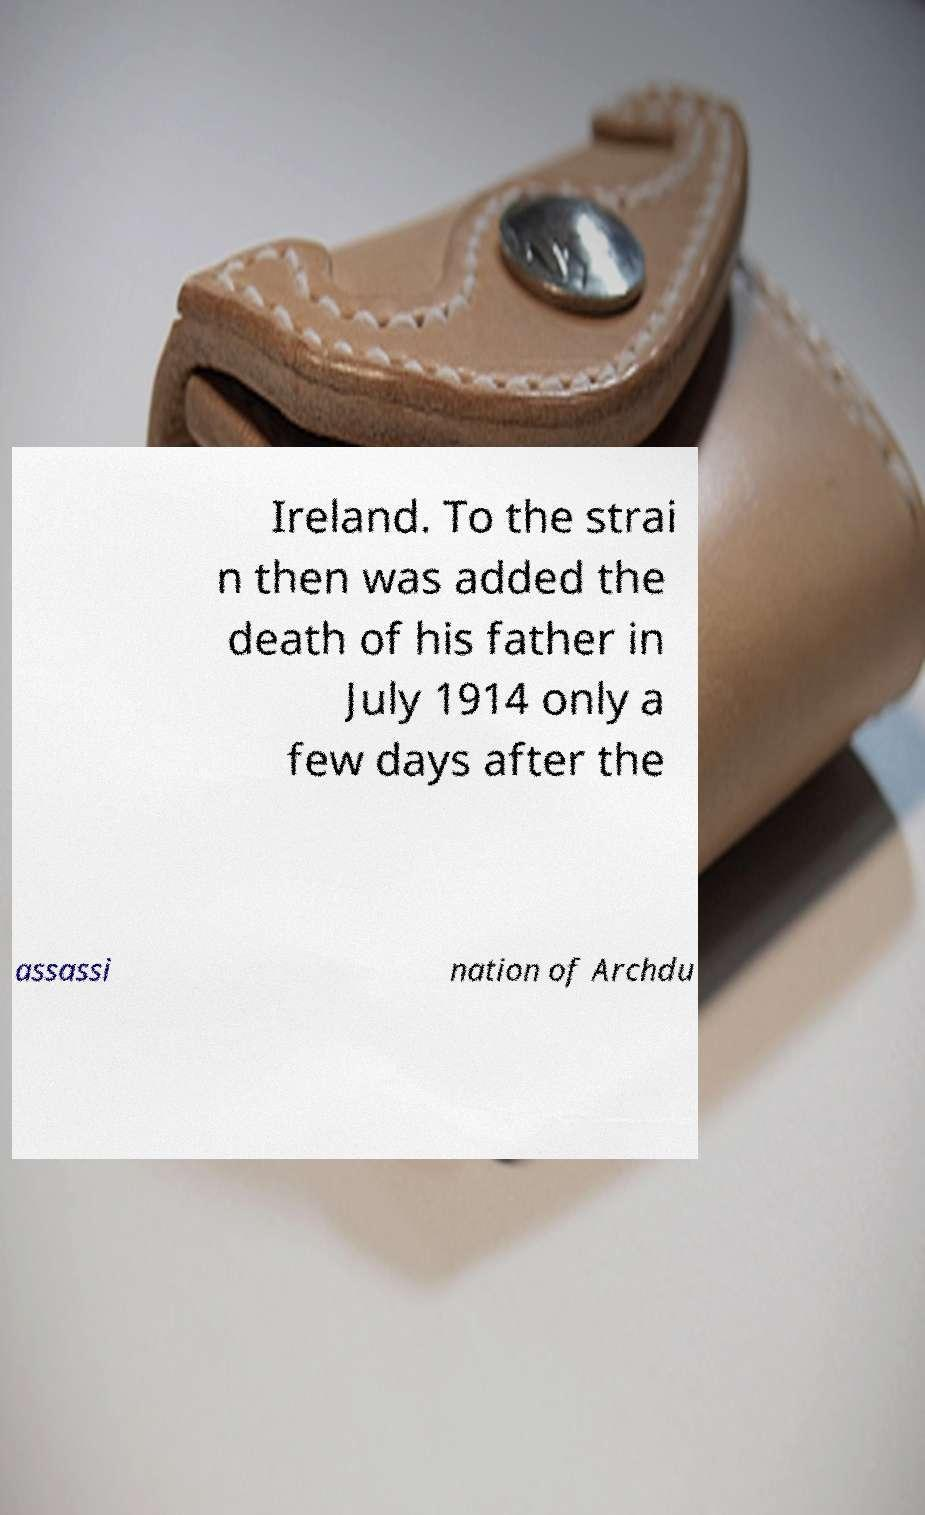For documentation purposes, I need the text within this image transcribed. Could you provide that? Ireland. To the strai n then was added the death of his father in July 1914 only a few days after the assassi nation of Archdu 